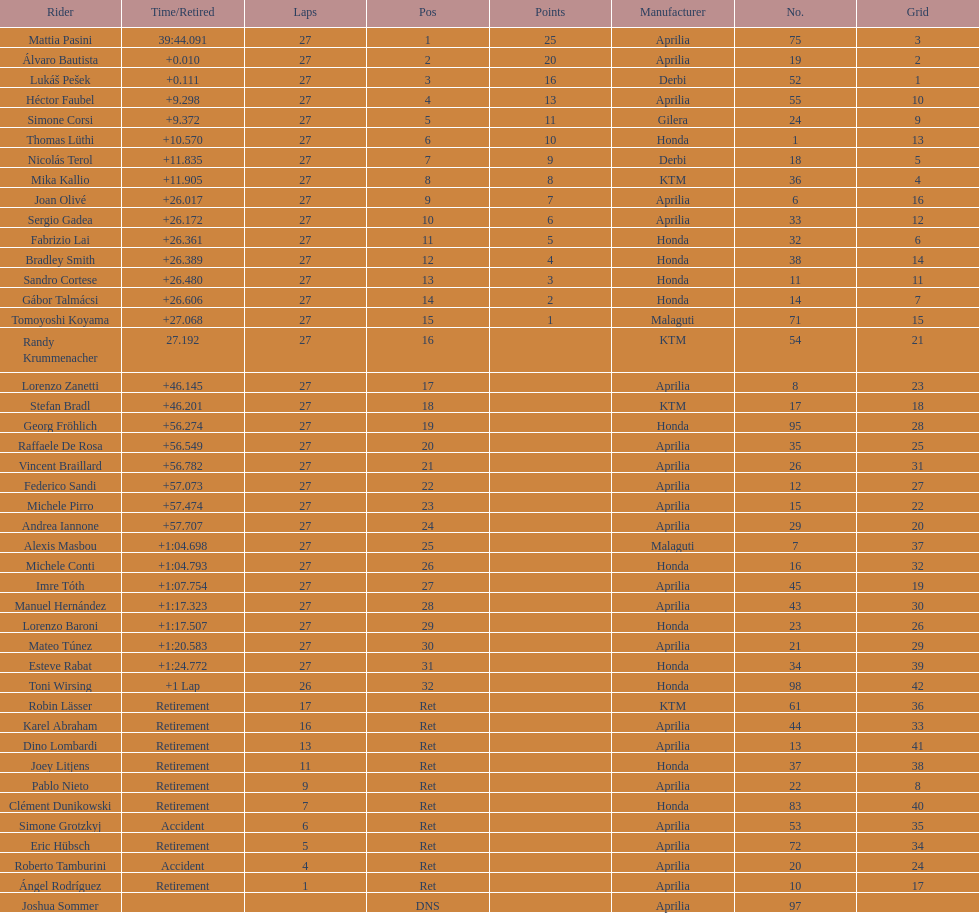How many positions were there in total within the 125cc classification? 43. 